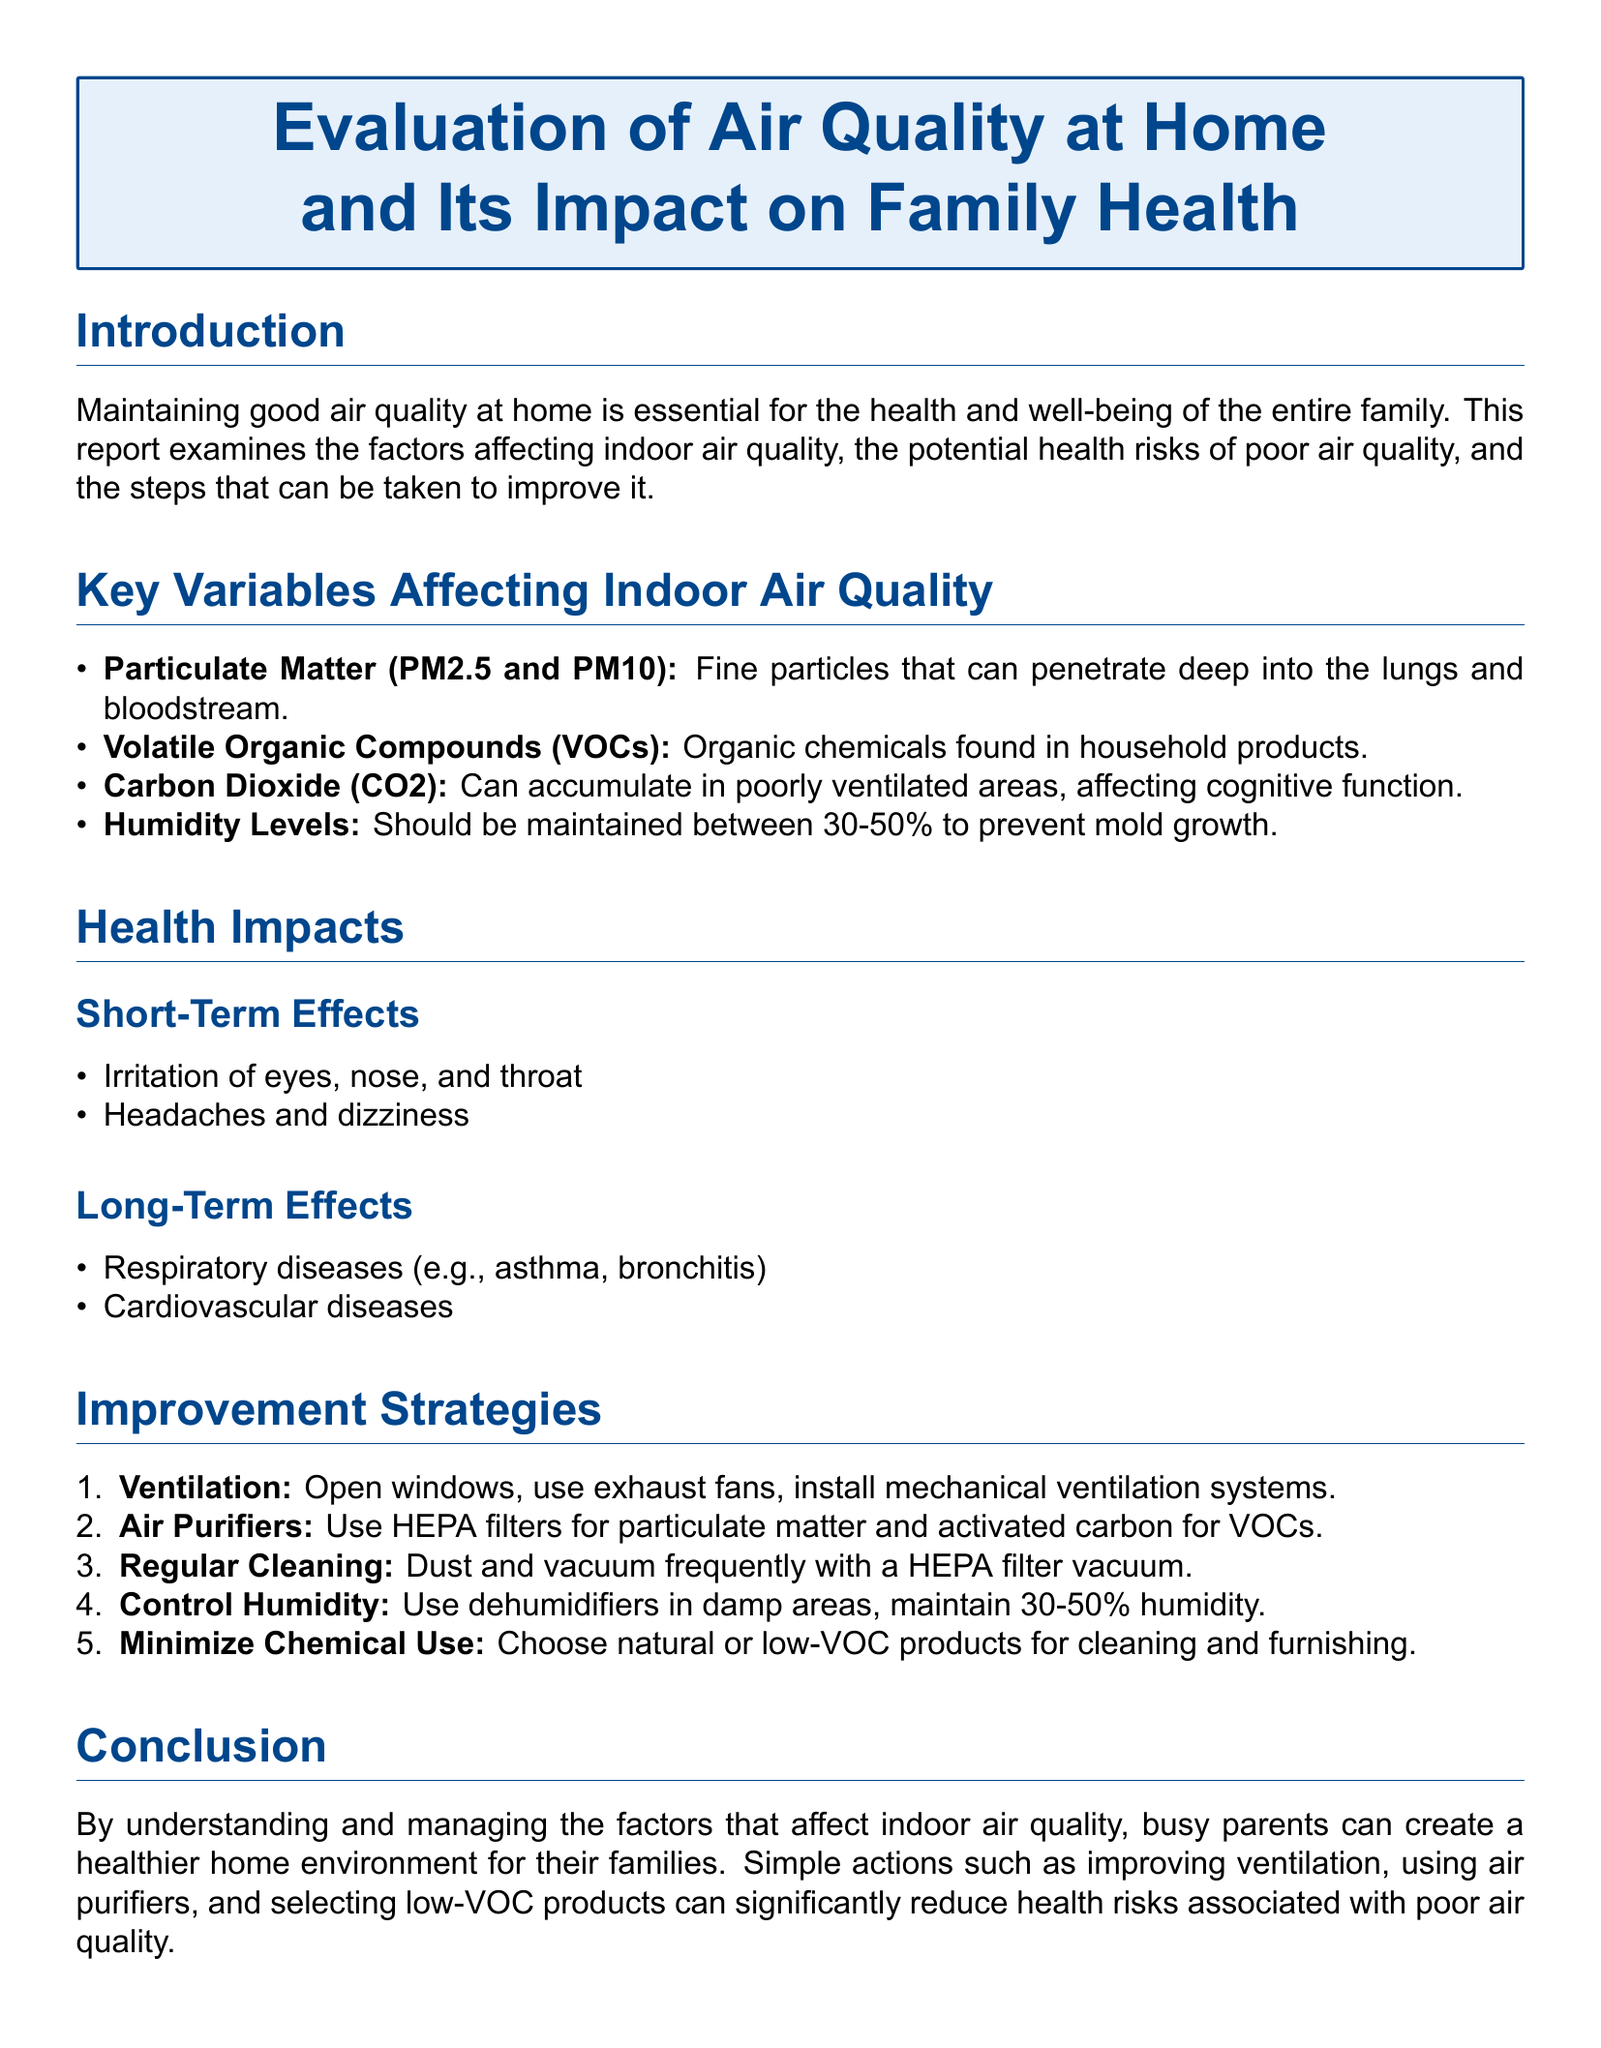what are the key variables affecting indoor air quality? The document lists four specific variables affecting indoor air quality: Particulate Matter, Volatile Organic Compounds, Carbon Dioxide, and Humidity Levels.
Answer: Particulate Matter, Volatile Organic Compounds, Carbon Dioxide, Humidity Levels what is the ideal humidity level for preventing mold growth? The document states that humidity levels should be maintained between 30-50% to prevent mold growth.
Answer: 30-50% what are the short-term effects of poor air quality? The document specifies two short-term effects: irritation of eyes, nose, and throat, and headaches and dizziness.
Answer: irritation of eyes, nose, and throat; headaches and dizziness what is a recommended strategy for improving ventilation? The document suggests several methods; one specific example mentioned is to open windows.
Answer: open windows what type of air filter is recommended for particulate matter? According to the report, HEPA filters are recommended for particulate matter.
Answer: HEPA filters how can parents minimize chemical use in their homes? The document advises choosing natural or low-VOC products for cleaning and furnishing as a way to minimize chemical use.
Answer: natural or low-VOC products what long-term health issues are associated with poor air quality? The report points out respiratory diseases and cardiovascular diseases as long-term health issues linked to poor air quality.
Answer: respiratory diseases; cardiovascular diseases what is the overall goal of this lab report? The document's goal is to help busy parents create a healthier home environment by managing air quality factors.
Answer: create a healthier home environment what type of document is this? The document is categorized under a specific type known as a lab report, focusing on air quality and health.
Answer: lab report 